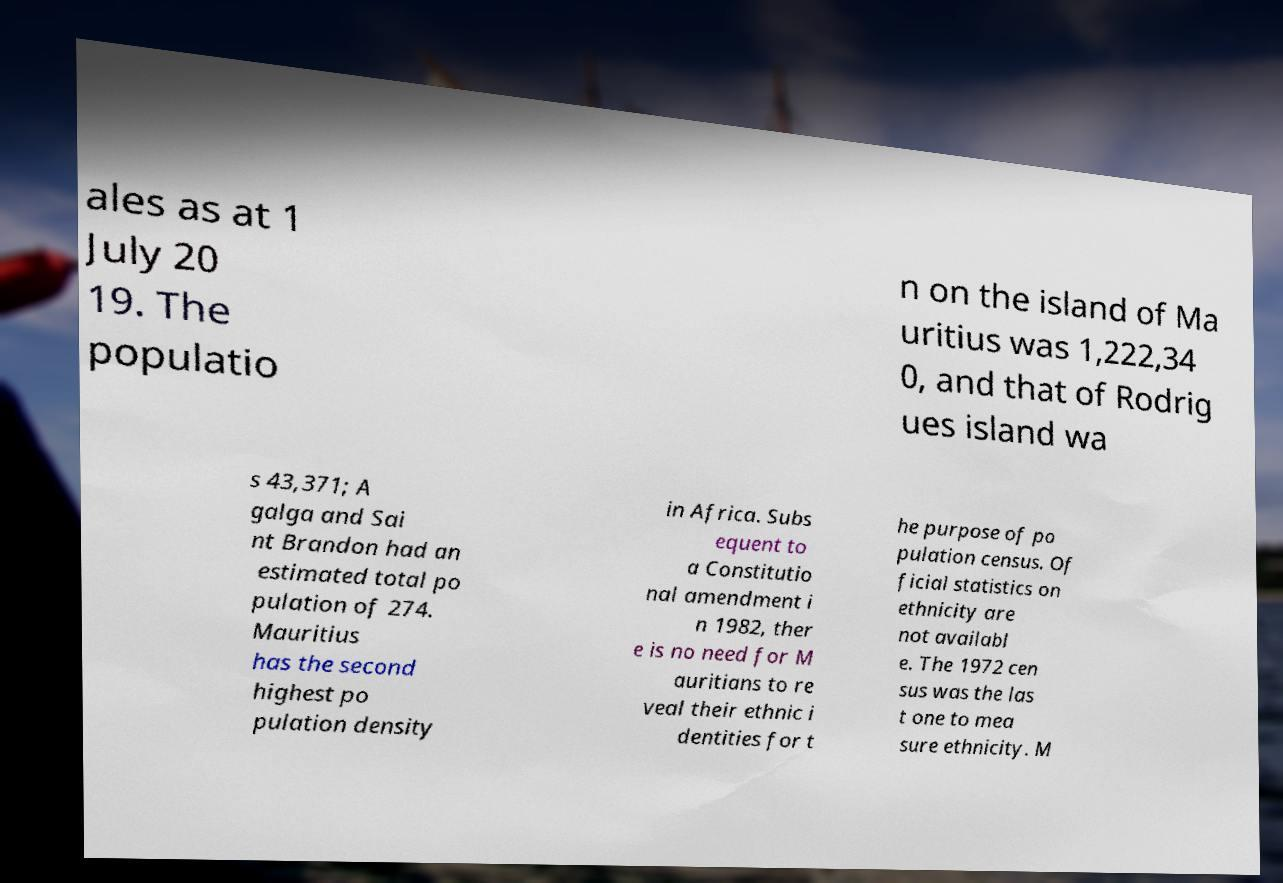Can you accurately transcribe the text from the provided image for me? ales as at 1 July 20 19. The populatio n on the island of Ma uritius was 1,222,34 0, and that of Rodrig ues island wa s 43,371; A galga and Sai nt Brandon had an estimated total po pulation of 274. Mauritius has the second highest po pulation density in Africa. Subs equent to a Constitutio nal amendment i n 1982, ther e is no need for M auritians to re veal their ethnic i dentities for t he purpose of po pulation census. Of ficial statistics on ethnicity are not availabl e. The 1972 cen sus was the las t one to mea sure ethnicity. M 